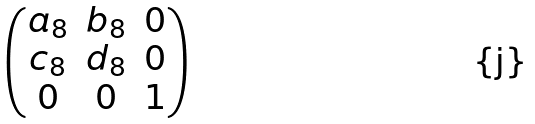<formula> <loc_0><loc_0><loc_500><loc_500>\begin{pmatrix} a _ { 8 } & b _ { 8 } & 0 \\ c _ { 8 } & d _ { 8 } & 0 \\ 0 & 0 & 1 \end{pmatrix}</formula> 